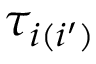<formula> <loc_0><loc_0><loc_500><loc_500>\tau _ { i ( i ^ { \prime } ) }</formula> 